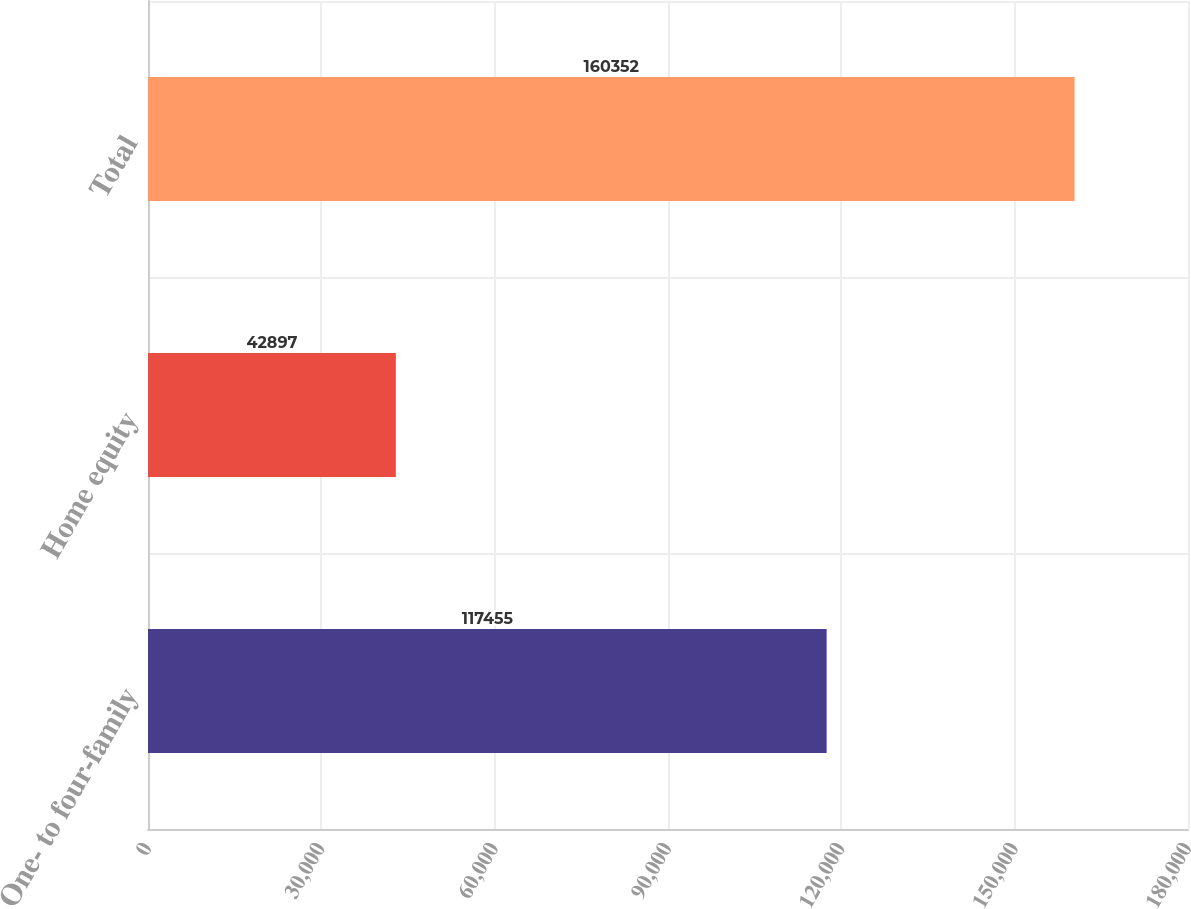Convert chart to OTSL. <chart><loc_0><loc_0><loc_500><loc_500><bar_chart><fcel>One- to four-family<fcel>Home equity<fcel>Total<nl><fcel>117455<fcel>42897<fcel>160352<nl></chart> 